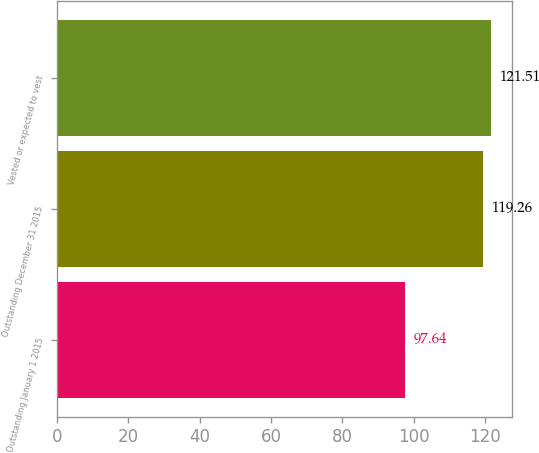Convert chart to OTSL. <chart><loc_0><loc_0><loc_500><loc_500><bar_chart><fcel>Outstanding January 1 2015<fcel>Outstanding December 31 2015<fcel>Vested or expected to vest<nl><fcel>97.64<fcel>119.26<fcel>121.51<nl></chart> 